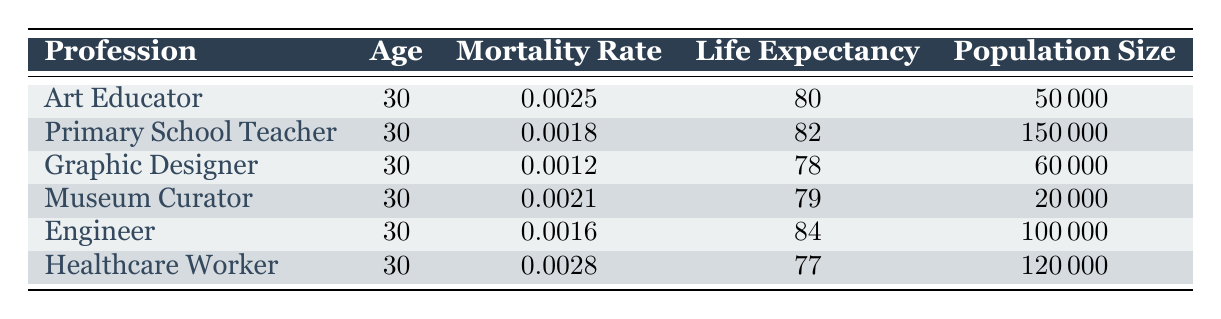What is the mortality rate for art educators? The table shows a specific row for "Art Educator" that lists the mortality rate as 0.0025.
Answer: 0.0025 Which profession has the highest life expectancy? The table shows the life expectancy for each profession. The engineer has the highest life expectancy at 84 years.
Answer: Engineer Is the mortality rate for healthcare workers higher than that of art educators? The mortality rate for healthcare workers is 0.0028, which is higher than the 0.0025 mortality rate for art educators.
Answer: Yes What is the difference in life expectancy between primary school teachers and graphic designers? Primary school teachers have a life expectancy of 82, whereas graphic designers have a life expectancy of 78. The difference is 82 - 78 = 4 years.
Answer: 4 years How many total people are represented in the data for all professions listed? To get the total population, we sum the population sizes: 50000 + 150000 + 60000 + 20000 + 100000 + 120000 = 500000.
Answer: 500000 Do museum curators have a lower mortality rate than graphic designers? The table shows that museum curators have a mortality rate of 0.0021 while graphic designers have a mortality rate of 0.0012. Therefore, museum curators do not have a lower mortality rate.
Answer: No What is the average life expectancy of art educators and primary school teachers? The life expectancy of art educators is 80 years, and for primary school teachers, it is 82 years. To find the average, we calculate (80 + 82) / 2 = 81.
Answer: 81 Which two professions have mortality rates below 0.0025? From the table, the professions with lower mortality rates than 0.0025 are graphic designers (0.0012) and primary school teachers (0.0018).
Answer: Graphic Designer, Primary School Teacher What is the total difference in the population size between healthcare workers and museum curators? The population size for healthcare workers is 120000, and for museum curators, it is 20000. The difference is 120000 - 20000 = 100000.
Answer: 100000 